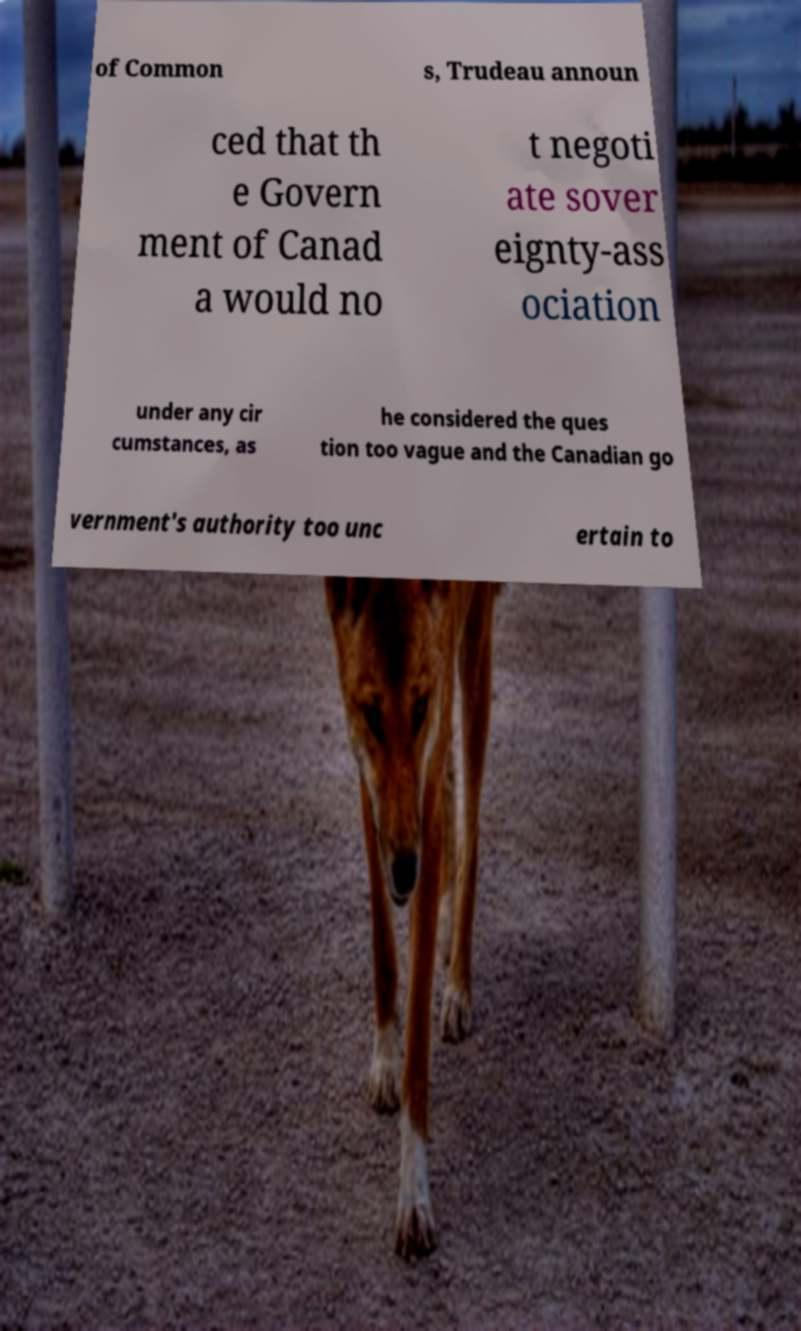Can you accurately transcribe the text from the provided image for me? of Common s, Trudeau announ ced that th e Govern ment of Canad a would no t negoti ate sover eignty-ass ociation under any cir cumstances, as he considered the ques tion too vague and the Canadian go vernment's authority too unc ertain to 